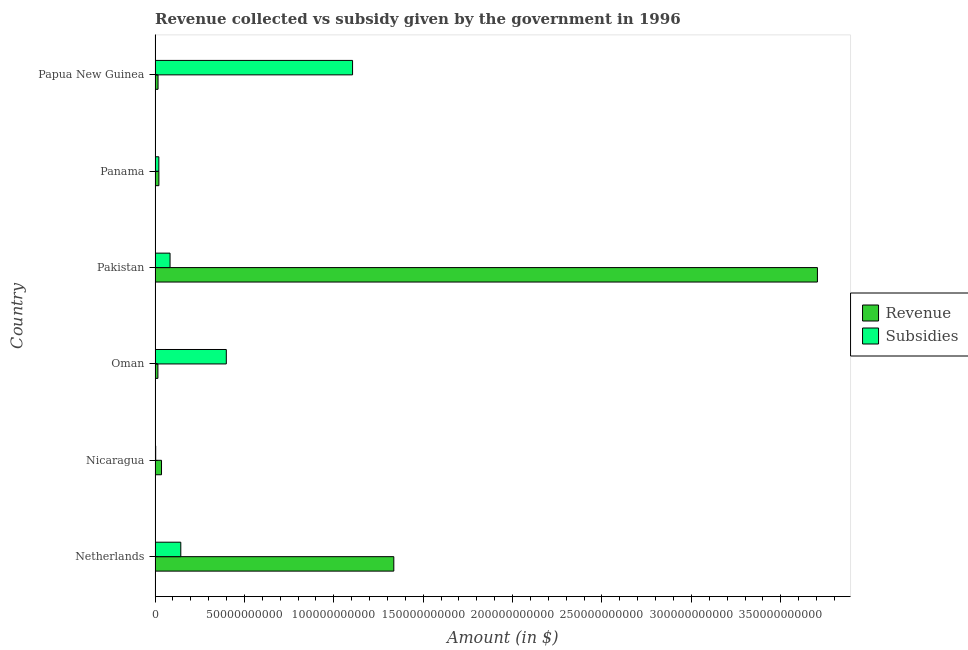How many groups of bars are there?
Provide a short and direct response. 6. Are the number of bars on each tick of the Y-axis equal?
Your answer should be compact. Yes. How many bars are there on the 3rd tick from the top?
Your answer should be very brief. 2. In how many cases, is the number of bars for a given country not equal to the number of legend labels?
Offer a very short reply. 0. What is the amount of revenue collected in Nicaragua?
Your answer should be very brief. 3.61e+09. Across all countries, what is the maximum amount of revenue collected?
Your answer should be compact. 3.71e+11. Across all countries, what is the minimum amount of subsidies given?
Provide a short and direct response. 3.62e+08. In which country was the amount of revenue collected maximum?
Your response must be concise. Pakistan. In which country was the amount of revenue collected minimum?
Keep it short and to the point. Oman. What is the total amount of revenue collected in the graph?
Make the answer very short. 5.13e+11. What is the difference between the amount of subsidies given in Nicaragua and that in Pakistan?
Your answer should be compact. -8.02e+09. What is the difference between the amount of revenue collected in Pakistan and the amount of subsidies given in Netherlands?
Keep it short and to the point. 3.56e+11. What is the average amount of revenue collected per country?
Your answer should be compact. 8.55e+1. What is the difference between the amount of subsidies given and amount of revenue collected in Nicaragua?
Ensure brevity in your answer.  -3.25e+09. In how many countries, is the amount of subsidies given greater than 230000000000 $?
Keep it short and to the point. 0. What is the ratio of the amount of revenue collected in Netherlands to that in Oman?
Your response must be concise. 83.94. What is the difference between the highest and the second highest amount of subsidies given?
Provide a succinct answer. 7.06e+1. What is the difference between the highest and the lowest amount of subsidies given?
Keep it short and to the point. 1.10e+11. In how many countries, is the amount of revenue collected greater than the average amount of revenue collected taken over all countries?
Your response must be concise. 2. What does the 2nd bar from the top in Papua New Guinea represents?
Your answer should be very brief. Revenue. What does the 2nd bar from the bottom in Papua New Guinea represents?
Keep it short and to the point. Subsidies. How many bars are there?
Your answer should be compact. 12. What is the difference between two consecutive major ticks on the X-axis?
Give a very brief answer. 5.00e+1. What is the title of the graph?
Provide a short and direct response. Revenue collected vs subsidy given by the government in 1996. Does "Private creditors" appear as one of the legend labels in the graph?
Provide a short and direct response. No. What is the label or title of the X-axis?
Your answer should be very brief. Amount (in $). What is the Amount (in $) in Revenue in Netherlands?
Give a very brief answer. 1.34e+11. What is the Amount (in $) of Subsidies in Netherlands?
Give a very brief answer. 1.44e+1. What is the Amount (in $) in Revenue in Nicaragua?
Give a very brief answer. 3.61e+09. What is the Amount (in $) in Subsidies in Nicaragua?
Offer a very short reply. 3.62e+08. What is the Amount (in $) of Revenue in Oman?
Give a very brief answer. 1.59e+09. What is the Amount (in $) in Subsidies in Oman?
Provide a short and direct response. 3.99e+1. What is the Amount (in $) of Revenue in Pakistan?
Make the answer very short. 3.71e+11. What is the Amount (in $) in Subsidies in Pakistan?
Offer a very short reply. 8.39e+09. What is the Amount (in $) of Revenue in Panama?
Provide a short and direct response. 2.14e+09. What is the Amount (in $) in Subsidies in Panama?
Make the answer very short. 2.11e+09. What is the Amount (in $) of Revenue in Papua New Guinea?
Ensure brevity in your answer.  1.67e+09. What is the Amount (in $) of Subsidies in Papua New Guinea?
Keep it short and to the point. 1.10e+11. Across all countries, what is the maximum Amount (in $) in Revenue?
Keep it short and to the point. 3.71e+11. Across all countries, what is the maximum Amount (in $) of Subsidies?
Offer a very short reply. 1.10e+11. Across all countries, what is the minimum Amount (in $) in Revenue?
Give a very brief answer. 1.59e+09. Across all countries, what is the minimum Amount (in $) of Subsidies?
Give a very brief answer. 3.62e+08. What is the total Amount (in $) of Revenue in the graph?
Your answer should be very brief. 5.13e+11. What is the total Amount (in $) of Subsidies in the graph?
Your answer should be very brief. 1.76e+11. What is the difference between the Amount (in $) of Revenue in Netherlands and that in Nicaragua?
Your answer should be very brief. 1.30e+11. What is the difference between the Amount (in $) in Subsidies in Netherlands and that in Nicaragua?
Offer a very short reply. 1.40e+1. What is the difference between the Amount (in $) of Revenue in Netherlands and that in Oman?
Provide a succinct answer. 1.32e+11. What is the difference between the Amount (in $) in Subsidies in Netherlands and that in Oman?
Keep it short and to the point. -2.55e+1. What is the difference between the Amount (in $) in Revenue in Netherlands and that in Pakistan?
Your response must be concise. -2.37e+11. What is the difference between the Amount (in $) in Subsidies in Netherlands and that in Pakistan?
Offer a very short reply. 6.01e+09. What is the difference between the Amount (in $) of Revenue in Netherlands and that in Panama?
Provide a short and direct response. 1.31e+11. What is the difference between the Amount (in $) of Subsidies in Netherlands and that in Panama?
Keep it short and to the point. 1.23e+1. What is the difference between the Amount (in $) of Revenue in Netherlands and that in Papua New Guinea?
Offer a terse response. 1.32e+11. What is the difference between the Amount (in $) of Subsidies in Netherlands and that in Papua New Guinea?
Keep it short and to the point. -9.61e+1. What is the difference between the Amount (in $) in Revenue in Nicaragua and that in Oman?
Give a very brief answer. 2.02e+09. What is the difference between the Amount (in $) in Subsidies in Nicaragua and that in Oman?
Keep it short and to the point. -3.95e+1. What is the difference between the Amount (in $) in Revenue in Nicaragua and that in Pakistan?
Your response must be concise. -3.67e+11. What is the difference between the Amount (in $) in Subsidies in Nicaragua and that in Pakistan?
Give a very brief answer. -8.02e+09. What is the difference between the Amount (in $) of Revenue in Nicaragua and that in Panama?
Your answer should be very brief. 1.47e+09. What is the difference between the Amount (in $) in Subsidies in Nicaragua and that in Panama?
Provide a succinct answer. -1.75e+09. What is the difference between the Amount (in $) in Revenue in Nicaragua and that in Papua New Guinea?
Provide a short and direct response. 1.94e+09. What is the difference between the Amount (in $) in Subsidies in Nicaragua and that in Papua New Guinea?
Ensure brevity in your answer.  -1.10e+11. What is the difference between the Amount (in $) of Revenue in Oman and that in Pakistan?
Make the answer very short. -3.69e+11. What is the difference between the Amount (in $) of Subsidies in Oman and that in Pakistan?
Provide a short and direct response. 3.15e+1. What is the difference between the Amount (in $) of Revenue in Oman and that in Panama?
Offer a terse response. -5.48e+08. What is the difference between the Amount (in $) of Subsidies in Oman and that in Panama?
Keep it short and to the point. 3.77e+1. What is the difference between the Amount (in $) of Revenue in Oman and that in Papua New Guinea?
Provide a succinct answer. -7.68e+07. What is the difference between the Amount (in $) in Subsidies in Oman and that in Papua New Guinea?
Give a very brief answer. -7.06e+1. What is the difference between the Amount (in $) of Revenue in Pakistan and that in Panama?
Offer a terse response. 3.68e+11. What is the difference between the Amount (in $) in Subsidies in Pakistan and that in Panama?
Your response must be concise. 6.27e+09. What is the difference between the Amount (in $) in Revenue in Pakistan and that in Papua New Guinea?
Ensure brevity in your answer.  3.69e+11. What is the difference between the Amount (in $) of Subsidies in Pakistan and that in Papua New Guinea?
Keep it short and to the point. -1.02e+11. What is the difference between the Amount (in $) of Revenue in Panama and that in Papua New Guinea?
Keep it short and to the point. 4.71e+08. What is the difference between the Amount (in $) in Subsidies in Panama and that in Papua New Guinea?
Offer a very short reply. -1.08e+11. What is the difference between the Amount (in $) of Revenue in Netherlands and the Amount (in $) of Subsidies in Nicaragua?
Provide a short and direct response. 1.33e+11. What is the difference between the Amount (in $) of Revenue in Netherlands and the Amount (in $) of Subsidies in Oman?
Ensure brevity in your answer.  9.37e+1. What is the difference between the Amount (in $) in Revenue in Netherlands and the Amount (in $) in Subsidies in Pakistan?
Provide a short and direct response. 1.25e+11. What is the difference between the Amount (in $) in Revenue in Netherlands and the Amount (in $) in Subsidies in Panama?
Provide a succinct answer. 1.31e+11. What is the difference between the Amount (in $) of Revenue in Netherlands and the Amount (in $) of Subsidies in Papua New Guinea?
Your answer should be compact. 2.31e+1. What is the difference between the Amount (in $) of Revenue in Nicaragua and the Amount (in $) of Subsidies in Oman?
Keep it short and to the point. -3.62e+1. What is the difference between the Amount (in $) of Revenue in Nicaragua and the Amount (in $) of Subsidies in Pakistan?
Offer a terse response. -4.77e+09. What is the difference between the Amount (in $) in Revenue in Nicaragua and the Amount (in $) in Subsidies in Panama?
Your answer should be very brief. 1.50e+09. What is the difference between the Amount (in $) in Revenue in Nicaragua and the Amount (in $) in Subsidies in Papua New Guinea?
Give a very brief answer. -1.07e+11. What is the difference between the Amount (in $) of Revenue in Oman and the Amount (in $) of Subsidies in Pakistan?
Offer a terse response. -6.80e+09. What is the difference between the Amount (in $) of Revenue in Oman and the Amount (in $) of Subsidies in Panama?
Offer a very short reply. -5.22e+08. What is the difference between the Amount (in $) of Revenue in Oman and the Amount (in $) of Subsidies in Papua New Guinea?
Provide a succinct answer. -1.09e+11. What is the difference between the Amount (in $) of Revenue in Pakistan and the Amount (in $) of Subsidies in Panama?
Offer a very short reply. 3.68e+11. What is the difference between the Amount (in $) of Revenue in Pakistan and the Amount (in $) of Subsidies in Papua New Guinea?
Offer a very short reply. 2.60e+11. What is the difference between the Amount (in $) in Revenue in Panama and the Amount (in $) in Subsidies in Papua New Guinea?
Make the answer very short. -1.08e+11. What is the average Amount (in $) of Revenue per country?
Offer a very short reply. 8.55e+1. What is the average Amount (in $) of Subsidies per country?
Make the answer very short. 2.93e+1. What is the difference between the Amount (in $) in Revenue and Amount (in $) in Subsidies in Netherlands?
Your response must be concise. 1.19e+11. What is the difference between the Amount (in $) in Revenue and Amount (in $) in Subsidies in Nicaragua?
Offer a very short reply. 3.25e+09. What is the difference between the Amount (in $) of Revenue and Amount (in $) of Subsidies in Oman?
Make the answer very short. -3.83e+1. What is the difference between the Amount (in $) in Revenue and Amount (in $) in Subsidies in Pakistan?
Keep it short and to the point. 3.62e+11. What is the difference between the Amount (in $) of Revenue and Amount (in $) of Subsidies in Panama?
Provide a short and direct response. 2.60e+07. What is the difference between the Amount (in $) of Revenue and Amount (in $) of Subsidies in Papua New Guinea?
Provide a short and direct response. -1.09e+11. What is the ratio of the Amount (in $) of Revenue in Netherlands to that in Nicaragua?
Give a very brief answer. 36.97. What is the ratio of the Amount (in $) in Subsidies in Netherlands to that in Nicaragua?
Give a very brief answer. 39.83. What is the ratio of the Amount (in $) of Revenue in Netherlands to that in Oman?
Provide a succinct answer. 83.95. What is the ratio of the Amount (in $) in Subsidies in Netherlands to that in Oman?
Your answer should be very brief. 0.36. What is the ratio of the Amount (in $) in Revenue in Netherlands to that in Pakistan?
Your response must be concise. 0.36. What is the ratio of the Amount (in $) in Subsidies in Netherlands to that in Pakistan?
Your answer should be very brief. 1.72. What is the ratio of the Amount (in $) in Revenue in Netherlands to that in Panama?
Provide a short and direct response. 62.44. What is the ratio of the Amount (in $) of Subsidies in Netherlands to that in Panama?
Provide a succinct answer. 6.82. What is the ratio of the Amount (in $) of Revenue in Netherlands to that in Papua New Guinea?
Provide a short and direct response. 80.08. What is the ratio of the Amount (in $) in Subsidies in Netherlands to that in Papua New Guinea?
Make the answer very short. 0.13. What is the ratio of the Amount (in $) of Revenue in Nicaragua to that in Oman?
Offer a very short reply. 2.27. What is the ratio of the Amount (in $) of Subsidies in Nicaragua to that in Oman?
Offer a terse response. 0.01. What is the ratio of the Amount (in $) of Revenue in Nicaragua to that in Pakistan?
Provide a short and direct response. 0.01. What is the ratio of the Amount (in $) in Subsidies in Nicaragua to that in Pakistan?
Provide a short and direct response. 0.04. What is the ratio of the Amount (in $) in Revenue in Nicaragua to that in Panama?
Your response must be concise. 1.69. What is the ratio of the Amount (in $) of Subsidies in Nicaragua to that in Panama?
Provide a short and direct response. 0.17. What is the ratio of the Amount (in $) in Revenue in Nicaragua to that in Papua New Guinea?
Your answer should be very brief. 2.17. What is the ratio of the Amount (in $) of Subsidies in Nicaragua to that in Papua New Guinea?
Your answer should be compact. 0. What is the ratio of the Amount (in $) of Revenue in Oman to that in Pakistan?
Your answer should be compact. 0. What is the ratio of the Amount (in $) of Subsidies in Oman to that in Pakistan?
Give a very brief answer. 4.75. What is the ratio of the Amount (in $) of Revenue in Oman to that in Panama?
Provide a succinct answer. 0.74. What is the ratio of the Amount (in $) of Subsidies in Oman to that in Panama?
Offer a terse response. 18.86. What is the ratio of the Amount (in $) of Revenue in Oman to that in Papua New Guinea?
Provide a short and direct response. 0.95. What is the ratio of the Amount (in $) in Subsidies in Oman to that in Papua New Guinea?
Provide a short and direct response. 0.36. What is the ratio of the Amount (in $) in Revenue in Pakistan to that in Panama?
Keep it short and to the point. 173.23. What is the ratio of the Amount (in $) of Subsidies in Pakistan to that in Panama?
Ensure brevity in your answer.  3.97. What is the ratio of the Amount (in $) in Revenue in Pakistan to that in Papua New Guinea?
Provide a succinct answer. 222.15. What is the ratio of the Amount (in $) in Subsidies in Pakistan to that in Papua New Guinea?
Provide a succinct answer. 0.08. What is the ratio of the Amount (in $) in Revenue in Panama to that in Papua New Guinea?
Make the answer very short. 1.28. What is the ratio of the Amount (in $) of Subsidies in Panama to that in Papua New Guinea?
Your response must be concise. 0.02. What is the difference between the highest and the second highest Amount (in $) in Revenue?
Make the answer very short. 2.37e+11. What is the difference between the highest and the second highest Amount (in $) of Subsidies?
Offer a terse response. 7.06e+1. What is the difference between the highest and the lowest Amount (in $) in Revenue?
Make the answer very short. 3.69e+11. What is the difference between the highest and the lowest Amount (in $) of Subsidies?
Offer a very short reply. 1.10e+11. 